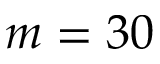<formula> <loc_0><loc_0><loc_500><loc_500>m = 3 0</formula> 